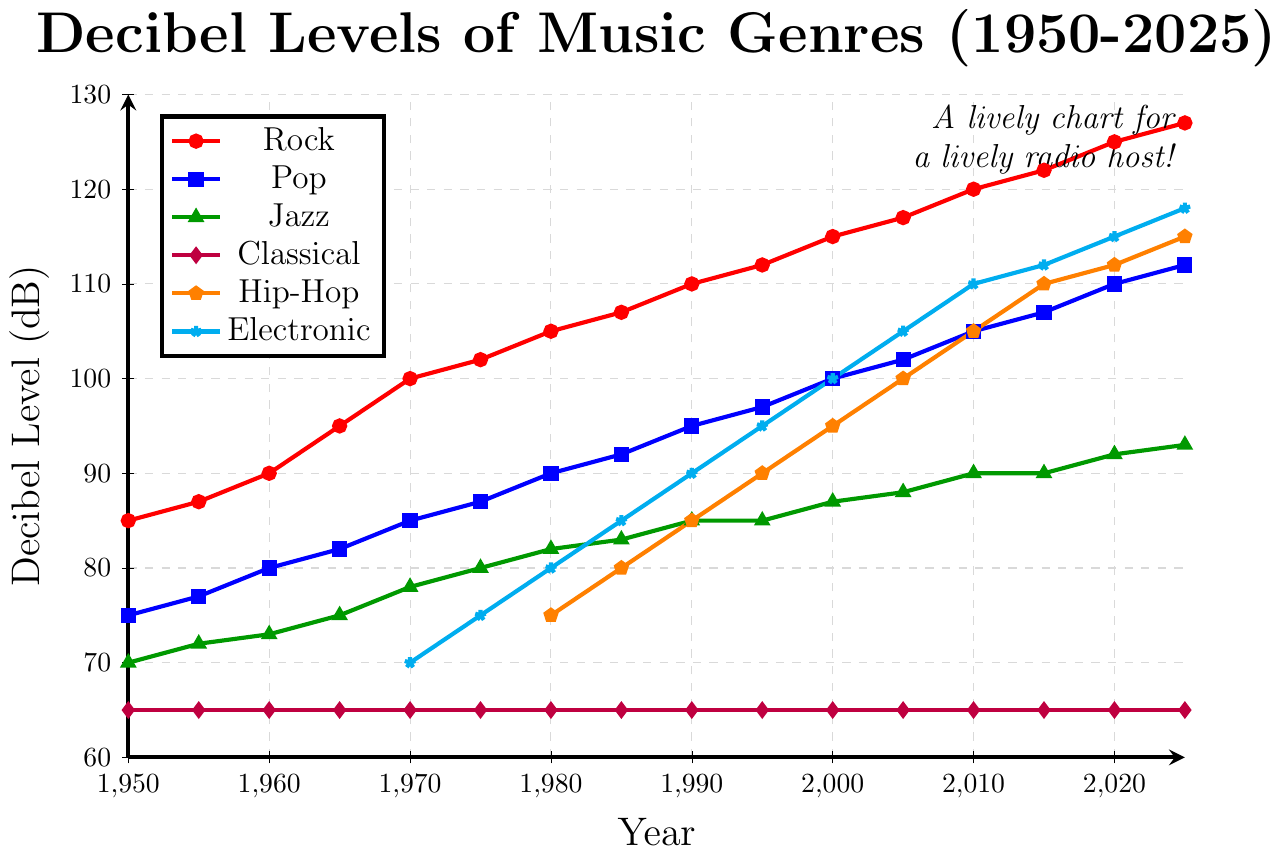What's the highest decibel level reached by the Rock genre? Look at the red line on the plot, which represents Rock. The highest point is at 2025 with a decibel level of 127.
Answer: 127 Which genre maintained the same decibel level throughout the years? The Classical genre, represented by the purple line, remained at 65 dB from 1950 to 2025.
Answer: Classical In which year did Hip-Hop reach a decibel level of 100? The orange line represents Hip-Hop. The point where the line hits 100 dB is in the year 2005.
Answer: 2005 Compare the decibel levels of Jazz and Pop in the year 1990. Which one was higher and by how much? Pop is the blue line and Jazz is the green line. In 1990, Pop is at 95 dB and Jazz is at 85 dB, so Pop is higher by 10 dB.
Answer: Pop by 10 Which genre had the biggest increase in decibel levels from 1950 to 2025? Calculate the difference for each genre between 1950 and 2025. Rock increases from 85 to 127 (42 dB), Pop from 75 to 112 (37 dB), Jazz from 70 to 93 (23 dB), Hip-Hop from 75 to 115 (40 dB), and Electronic from 70 to 118 (48 dB). Rock had the biggest increase (48 dB).
Answer: Electronic What was the decibel level of Electronic music in 1990? The cyan line represents Electronic. The point for 1990 is at 90 dB.
Answer: 90 Which genre witnessed the least change in decibel levels between 1950 and 2025? Classical maintains a constant decibel level at 65, showing no change.
Answer: Classical How much louder was Rock compared to Pop in the year 2020? In 2020, Rock (red line) is at 125 dB and Pop (blue line) is at 110 dB. The difference is 125 - 110 = 15 dB.
Answer: 15 By what year did all the genres exceed 90 decibels except for Classical? From the chart, by 2010, all genres except Classical (which remains at 65 dB) surpassed 90 dB.
Answer: 2010 What's the average decibel level of Jazz in the 1980s? Jazz (green line) has 3 points in the 1980s: 1980 (82 dB), 1985 (83 dB), 1990 (85 dB). The average is (82 + 83 + 85) / 3 = 83.33 dB.
Answer: 83.33 